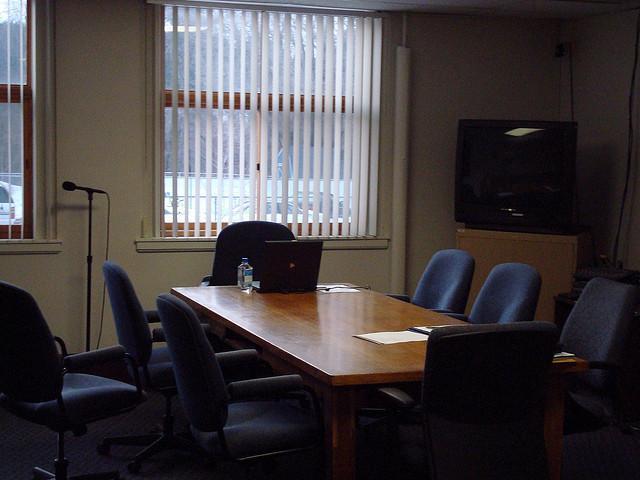How many chairs are there?
Give a very brief answer. 8. How many chairs?
Give a very brief answer. 8. How many seats are there?
Give a very brief answer. 8. How many cars are visible?
Give a very brief answer. 1. How many bike on this image?
Give a very brief answer. 0. 